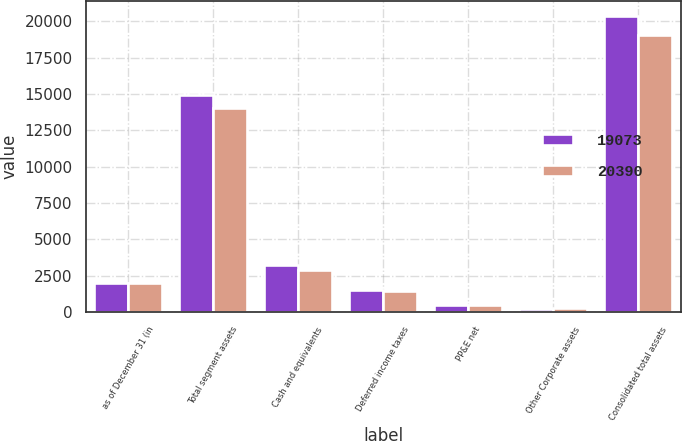Convert chart. <chart><loc_0><loc_0><loc_500><loc_500><stacked_bar_chart><ecel><fcel>as of December 31 (in<fcel>Total segment assets<fcel>Cash and equivalents<fcel>Deferred income taxes<fcel>PP&E net<fcel>Other Corporate assets<fcel>Consolidated total assets<nl><fcel>19073<fcel>2012<fcel>14948<fcel>3270<fcel>1500<fcel>461<fcel>211<fcel>20390<nl><fcel>20390<fcel>2011<fcel>14028<fcel>2905<fcel>1418<fcel>464<fcel>258<fcel>19073<nl></chart> 